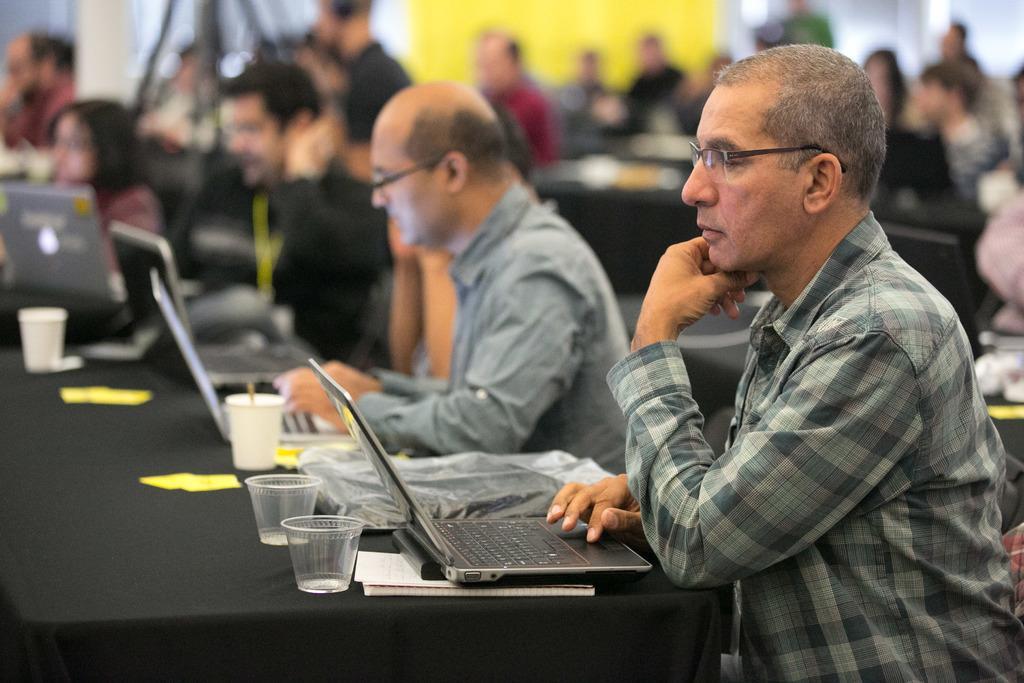In one or two sentences, can you explain what this image depicts? In this image there is one table on the bottom left side of this image and there are some laptops and some glasses are kept on it, and there are some persons are sitting around to this table, as we can see in middle of this image, and there are some persons sitting in the background. 